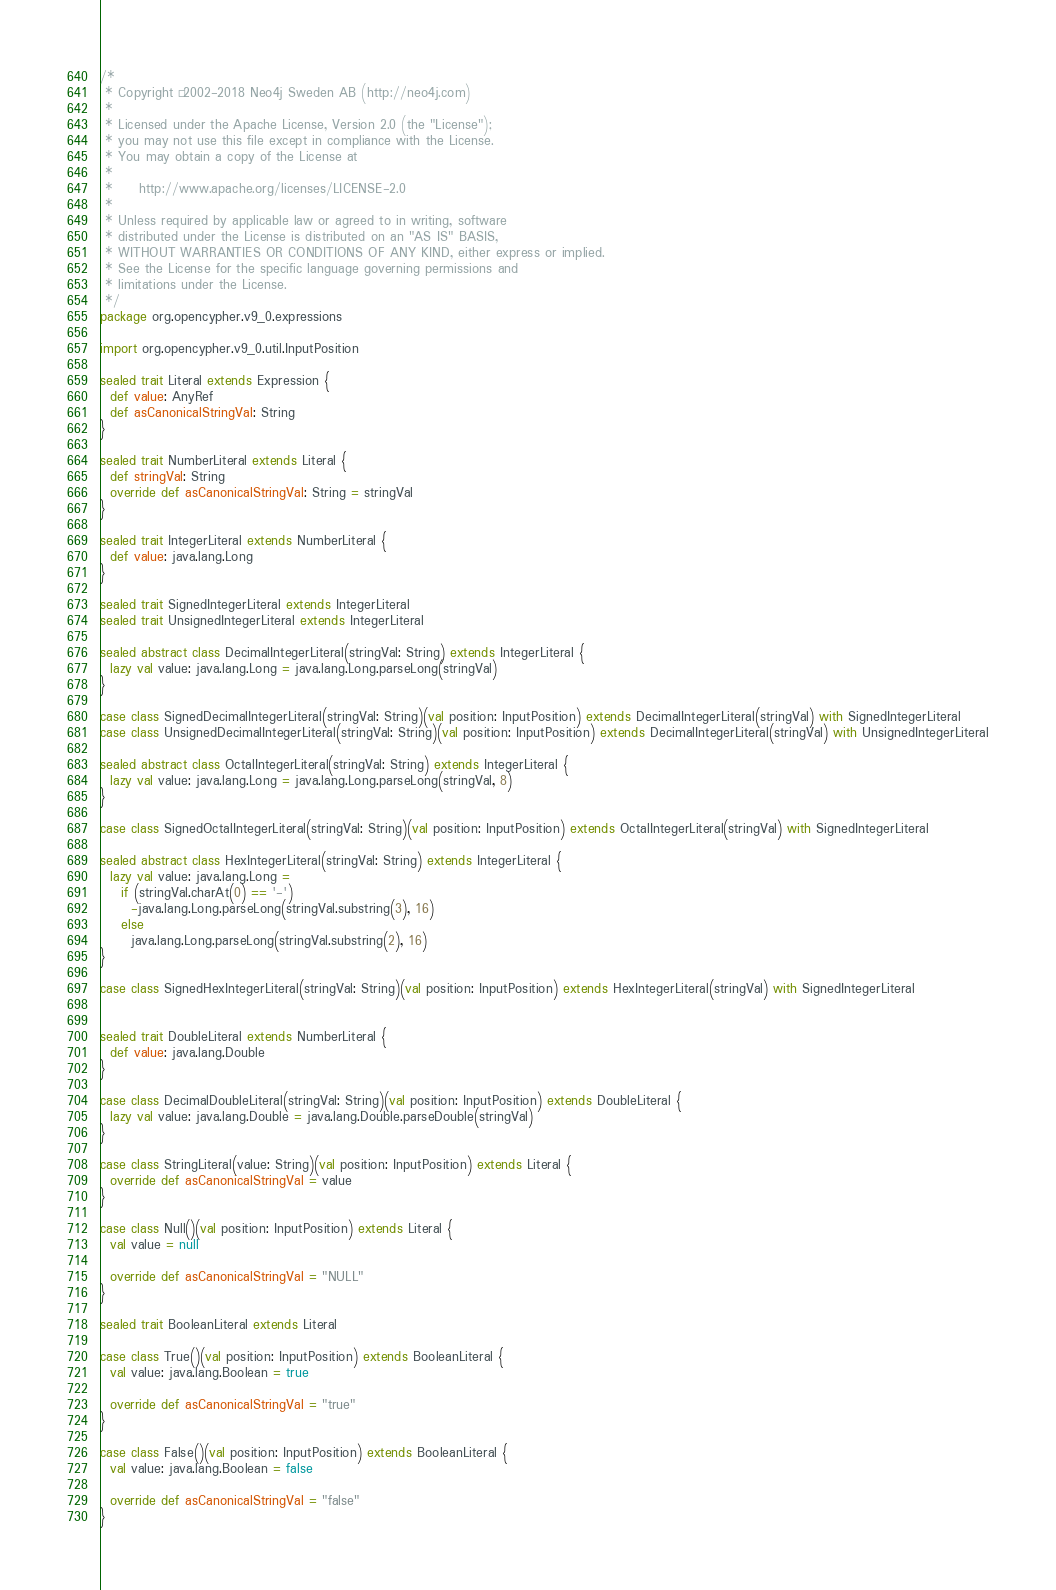<code> <loc_0><loc_0><loc_500><loc_500><_Scala_>/*
 * Copyright © 2002-2018 Neo4j Sweden AB (http://neo4j.com)
 *
 * Licensed under the Apache License, Version 2.0 (the "License");
 * you may not use this file except in compliance with the License.
 * You may obtain a copy of the License at
 *
 *     http://www.apache.org/licenses/LICENSE-2.0
 *
 * Unless required by applicable law or agreed to in writing, software
 * distributed under the License is distributed on an "AS IS" BASIS,
 * WITHOUT WARRANTIES OR CONDITIONS OF ANY KIND, either express or implied.
 * See the License for the specific language governing permissions and
 * limitations under the License.
 */
package org.opencypher.v9_0.expressions

import org.opencypher.v9_0.util.InputPosition

sealed trait Literal extends Expression {
  def value: AnyRef
  def asCanonicalStringVal: String
}

sealed trait NumberLiteral extends Literal {
  def stringVal: String
  override def asCanonicalStringVal: String = stringVal
}

sealed trait IntegerLiteral extends NumberLiteral {
  def value: java.lang.Long
}

sealed trait SignedIntegerLiteral extends IntegerLiteral
sealed trait UnsignedIntegerLiteral extends IntegerLiteral

sealed abstract class DecimalIntegerLiteral(stringVal: String) extends IntegerLiteral {
  lazy val value: java.lang.Long = java.lang.Long.parseLong(stringVal)
}

case class SignedDecimalIntegerLiteral(stringVal: String)(val position: InputPosition) extends DecimalIntegerLiteral(stringVal) with SignedIntegerLiteral
case class UnsignedDecimalIntegerLiteral(stringVal: String)(val position: InputPosition) extends DecimalIntegerLiteral(stringVal) with UnsignedIntegerLiteral

sealed abstract class OctalIntegerLiteral(stringVal: String) extends IntegerLiteral {
  lazy val value: java.lang.Long = java.lang.Long.parseLong(stringVal, 8)
}

case class SignedOctalIntegerLiteral(stringVal: String)(val position: InputPosition) extends OctalIntegerLiteral(stringVal) with SignedIntegerLiteral

sealed abstract class HexIntegerLiteral(stringVal: String) extends IntegerLiteral {
  lazy val value: java.lang.Long =
    if (stringVal.charAt(0) == '-')
      -java.lang.Long.parseLong(stringVal.substring(3), 16)
    else
      java.lang.Long.parseLong(stringVal.substring(2), 16)
}

case class SignedHexIntegerLiteral(stringVal: String)(val position: InputPosition) extends HexIntegerLiteral(stringVal) with SignedIntegerLiteral


sealed trait DoubleLiteral extends NumberLiteral {
  def value: java.lang.Double
}

case class DecimalDoubleLiteral(stringVal: String)(val position: InputPosition) extends DoubleLiteral {
  lazy val value: java.lang.Double = java.lang.Double.parseDouble(stringVal)
}

case class StringLiteral(value: String)(val position: InputPosition) extends Literal {
  override def asCanonicalStringVal = value
}

case class Null()(val position: InputPosition) extends Literal {
  val value = null

  override def asCanonicalStringVal = "NULL"
}

sealed trait BooleanLiteral extends Literal

case class True()(val position: InputPosition) extends BooleanLiteral {
  val value: java.lang.Boolean = true

  override def asCanonicalStringVal = "true"
}

case class False()(val position: InputPosition) extends BooleanLiteral {
  val value: java.lang.Boolean = false

  override def asCanonicalStringVal = "false"
}
</code> 